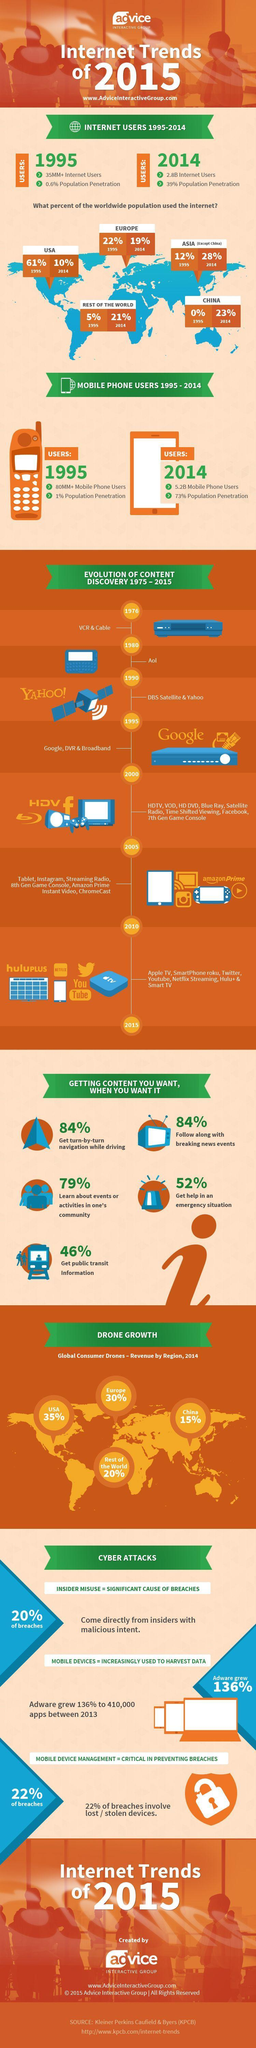What is the global consumer drones - revenue in rest of the world in 2014?
Answer the question with a short phrase. 20% What is the global consumer drones - revenue in China in 2014? 15% What is the percentage of people using internet in 1995 in Usa? 61% What is the percentage of people using internet in 2014 in Europe? 19% What is the difference in percentage of people using internet in 1995 and 2014 in China? 23% What is the global consumer drones - revenue in Europe in 2014? 30% What is the percentage of people using internet in 1995 in Europe? 22% What is the number of mobile phone users in 1995? 80MM+ What is the percentage difference of people using internet in 1995 and 2014 in USA? 51% What is the number of mobile phone users in 2014? 5.2B What is the global consumer drones - revenue in USA in 2014? 35% What is the percentage of people using internet in 2014 in USA? 10% 